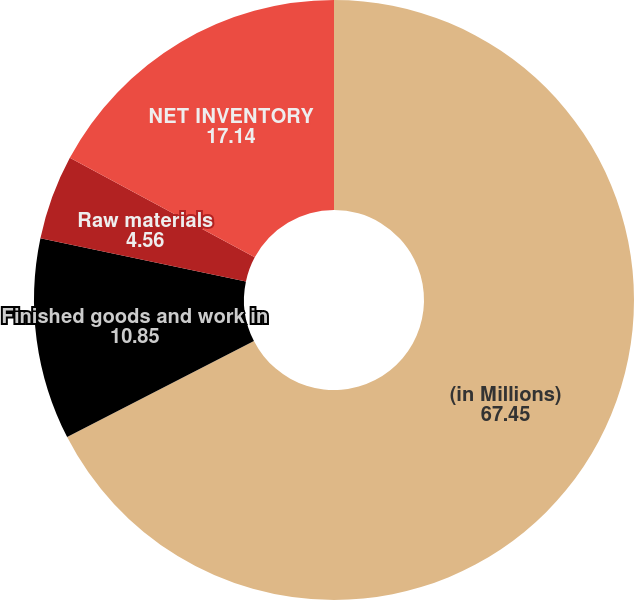Convert chart. <chart><loc_0><loc_0><loc_500><loc_500><pie_chart><fcel>(in Millions)<fcel>Finished goods and work in<fcel>Raw materials<fcel>NET INVENTORY<nl><fcel>67.45%<fcel>10.85%<fcel>4.56%<fcel>17.14%<nl></chart> 